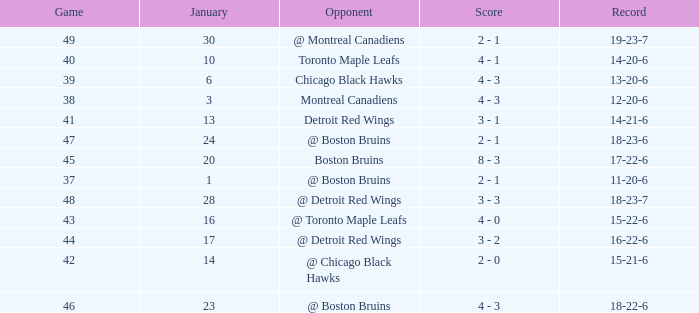What was the total number of games on January 20? 1.0. 